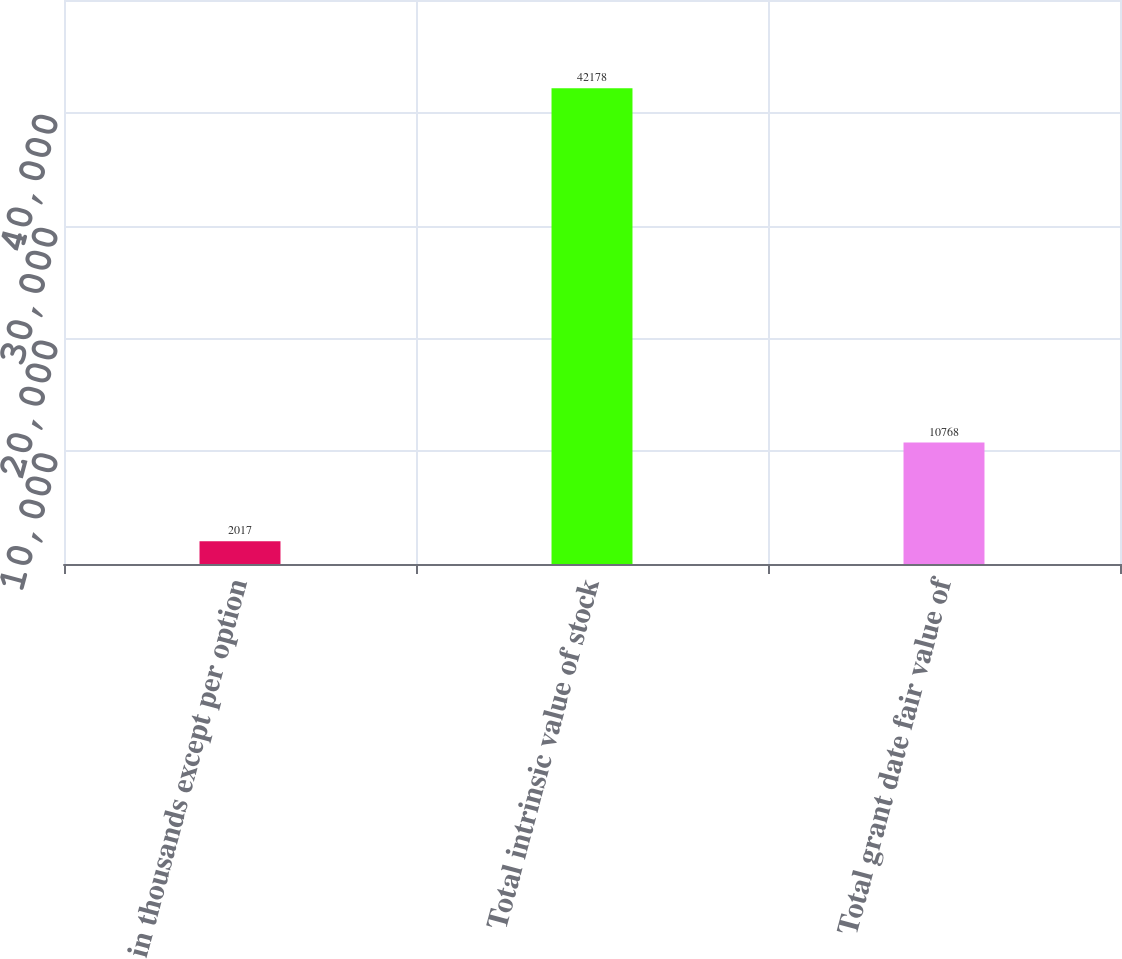Convert chart to OTSL. <chart><loc_0><loc_0><loc_500><loc_500><bar_chart><fcel>in thousands except per option<fcel>Total intrinsic value of stock<fcel>Total grant date fair value of<nl><fcel>2017<fcel>42178<fcel>10768<nl></chart> 